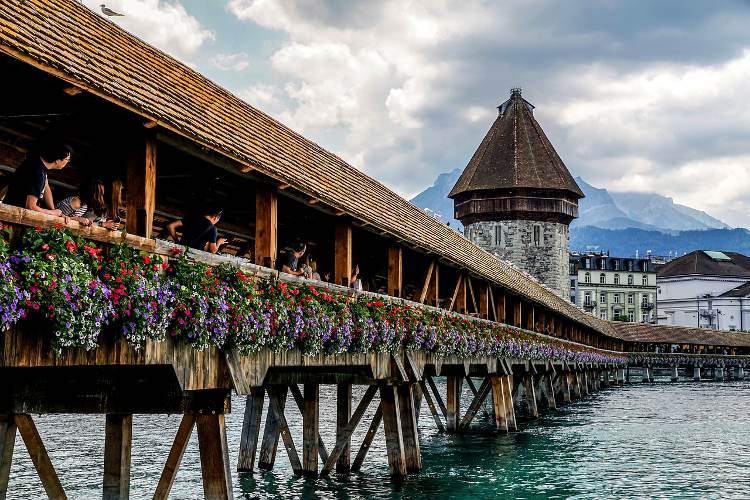Can you provide some historical context about this bridge? Certainly! The Chapel Bridge, or Kapellbrücke, is a significant landmark in Lucerne, Switzerland, constructed in the 14th century as part of the city's fortifications. The bridge was named after the nearby St. Peter's Chapel. Over the centuries, it has undergone several restorations, especially after a massive fire in 1993 which destroyed part of its wooden structure. The bridge is famous not only for its architecture but also for the series of 17th-century interior paintings that depict the history of Lucerne. Walking across the Chapel Bridge offers a journey through time, blending natural beauty with rich cultural heritage. 